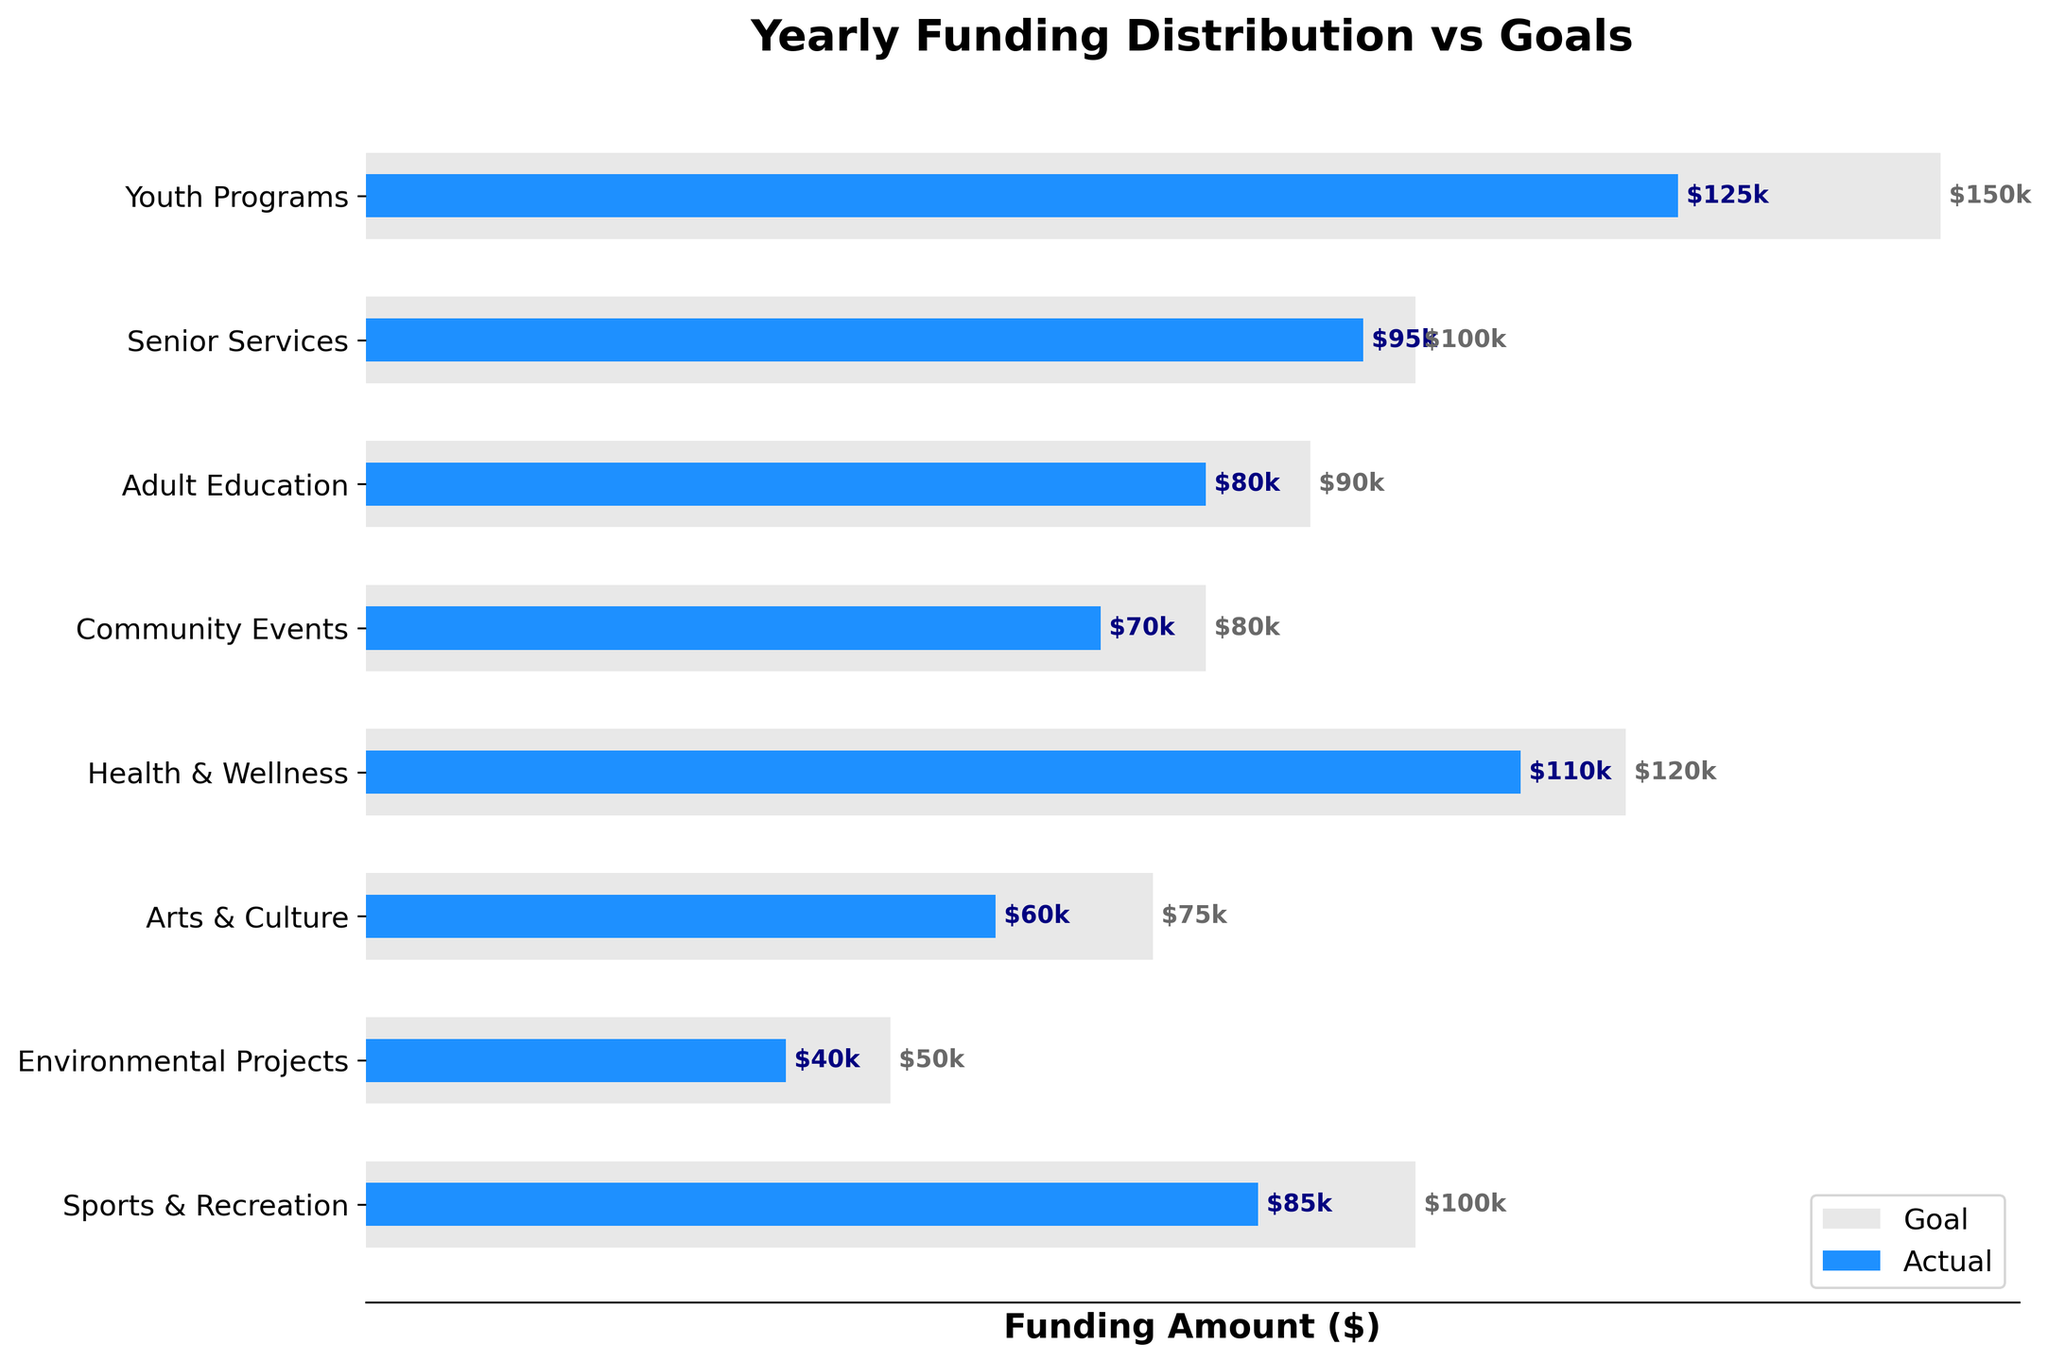What is the title of the figure? The title is usually located at the top of the figure. In this case, it reads 'Yearly Funding Distribution vs Goals'.
Answer: Yearly Funding Distribution vs Goals What are the initiatives included in the chart? The y-axis labels represent the initiatives. They include 'Youth Programs', 'Senior Services', 'Adult Education', 'Community Events', 'Health & Wellness', 'Arts & Culture', 'Environmental Projects', and 'Sports & Recreation'.
Answer: Youth Programs, Senior Services, Adult Education, Community Events, Health & Wellness, Arts & Culture, Environmental Projects, Sports & Recreation Which initiative received the highest actual funding? By observing the lengths of the blue bars, the initiative with the longest blue bar represents the highest actual funding, which is 'Youth Programs'.
Answer: Youth Programs What is the difference between the actual and goal funding for 'Arts & Culture'? Locate the 'Arts & Culture' initiative in the chart. The actual funding is $60,000 and the goal is $75,000. The difference is calculated as $75,000 - $60,000.
Answer: $15,000 How much less funding did 'Community Events' receive compared to its goal? Locate 'Community Events'. The actual funding is $70,000, and the goal is $80,000. The shortfall is $80,000 - $70,000.
Answer: $10,000 Which initiative had the smallest gap between actual funding and its goal? Calculate the differences between actual and goal funding for each initiative and compare them. The smallest gap is for 'Senior Services' ($100,000 - $95,000 = $5,000).
Answer: Senior Services What is the combined actual funding for 'Health & Wellness' and 'Sports & Recreation'? Add the actual funding for 'Health & Wellness ($110,000) and 'Sports & Recreation' ($85,000). The combined total is $110,000 + $85,000.
Answer: $195,000 Did any initiative meet or exceed its goal? Compare the actual funding to the goal for each initiative. None of the initiatives met or exceeded their goal.
Answer: No Which initiatives had a goal of $100,000? Identify the initiatives with a goal bar (grey color) ending at $100,000. 'Senior Services' and 'Sports & Recreation' have goals of $100,000.
Answer: Senior Services, Sports & Recreation 